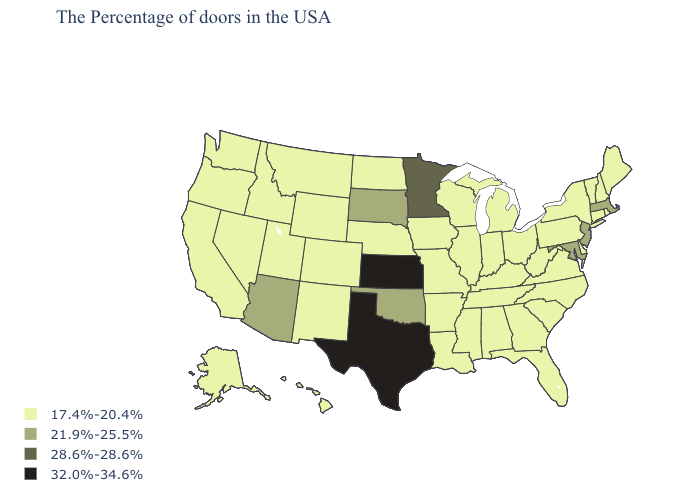What is the lowest value in states that border Alabama?
Write a very short answer. 17.4%-20.4%. Does Louisiana have the lowest value in the USA?
Give a very brief answer. Yes. What is the highest value in states that border California?
Give a very brief answer. 21.9%-25.5%. Name the states that have a value in the range 17.4%-20.4%?
Give a very brief answer. Maine, Rhode Island, New Hampshire, Vermont, Connecticut, New York, Delaware, Pennsylvania, Virginia, North Carolina, South Carolina, West Virginia, Ohio, Florida, Georgia, Michigan, Kentucky, Indiana, Alabama, Tennessee, Wisconsin, Illinois, Mississippi, Louisiana, Missouri, Arkansas, Iowa, Nebraska, North Dakota, Wyoming, Colorado, New Mexico, Utah, Montana, Idaho, Nevada, California, Washington, Oregon, Alaska, Hawaii. What is the lowest value in the USA?
Concise answer only. 17.4%-20.4%. What is the lowest value in states that border North Carolina?
Short answer required. 17.4%-20.4%. What is the value of Michigan?
Write a very short answer. 17.4%-20.4%. Does the map have missing data?
Keep it brief. No. Among the states that border Michigan , which have the highest value?
Short answer required. Ohio, Indiana, Wisconsin. What is the value of New York?
Keep it brief. 17.4%-20.4%. Does Washington have the lowest value in the USA?
Concise answer only. Yes. What is the value of Minnesota?
Write a very short answer. 28.6%-28.6%. Name the states that have a value in the range 28.6%-28.6%?
Keep it brief. Minnesota. Does Florida have a higher value than Ohio?
Concise answer only. No. 